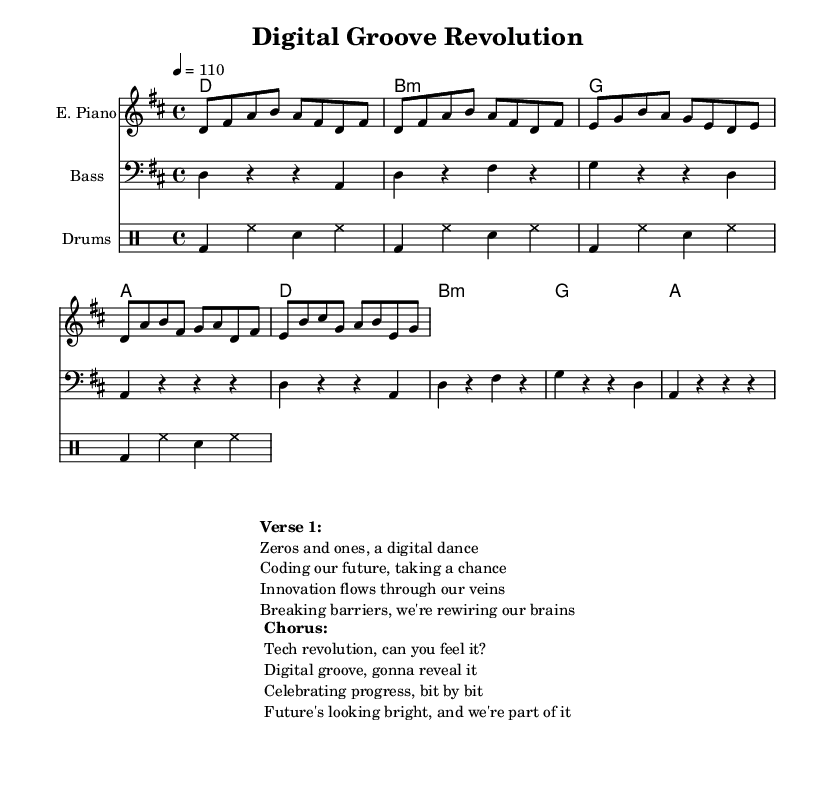What is the key signature of this music? The key signature is D major, indicated by the presence of two sharps (F# and C#).
Answer: D major What is the time signature of this music? The time signature is 4/4, meaning there are four beats in each measure with a quarter note getting one beat, as shown at the beginning of the score.
Answer: 4/4 What is the tempo marking of the piece? The tempo marking is 110 beats per minute, which is indicated by "4 = 110" at the beginning of the score, suggesting a moderate pace.
Answer: 110 How many measures are in the electric piano part? The electric piano part contains 10 measures, which can be counted visually from the beginning to the end of the music notation provided for that instrument.
Answer: 10 What type of instrument plays the bass part? The bass part is played by a bass guitar, as indicated by the instrument name in the staff heading.
Answer: Bass guitar What is the mood conveyed in the lyrics of the chorus? The mood conveyed in the chorus suggests optimism and excitement about technological progress and innovation, hinted at by phrases like "Future's looking bright."
Answer: Optimism How does the structure of the music reflect typical characteristics of neo-soul? The structure includes repetitive and melodic components with a groove-oriented rhythmic section, characteristic of neo-soul, emphasizing smooth harmonies and rhythmic complexity.
Answer: Groove-oriented 